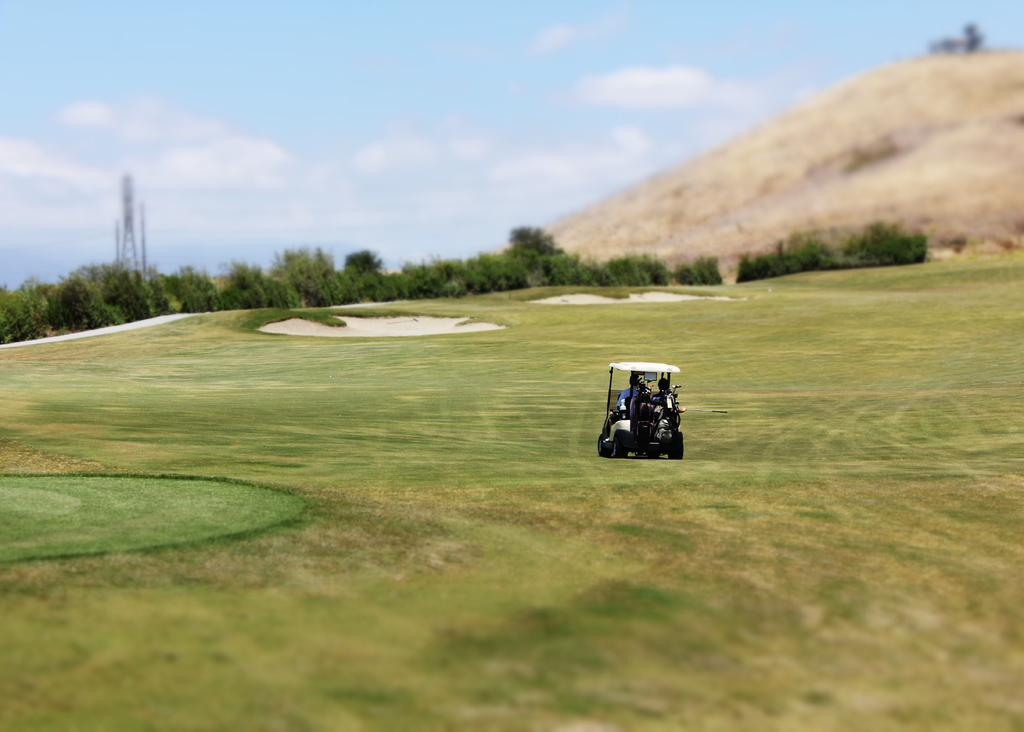How many people are in the image? There are two persons in the image. What are the persons doing in the image? The persons are riding a golf car. Where is the golf car located? The golf car is on a golf field. What can be seen in the background of the image? There are plants in the background of the image. What is the terrain like on the right side of the image? There is a hill on the right side of the image. What is visible in the sky in the image? The sky is visible in the image, and there are clouds in the sky. What type of oil is being used to lubricate the golf car in the image? There is no indication in the image that the golf car is being lubricated with oil, so it cannot be determined from the picture. 